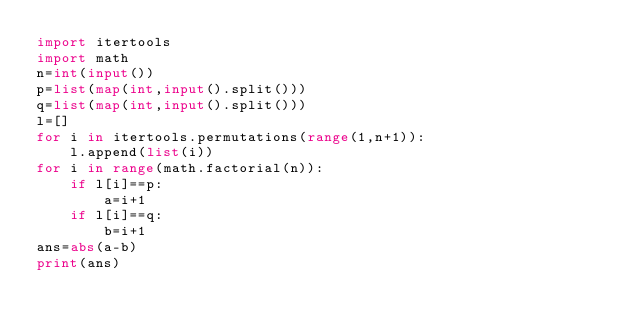<code> <loc_0><loc_0><loc_500><loc_500><_Python_>import itertools
import math
n=int(input())
p=list(map(int,input().split()))
q=list(map(int,input().split()))
l=[]
for i in itertools.permutations(range(1,n+1)):
    l.append(list(i))
for i in range(math.factorial(n)):
    if l[i]==p:
        a=i+1
    if l[i]==q:
        b=i+1
ans=abs(a-b)
print(ans)</code> 